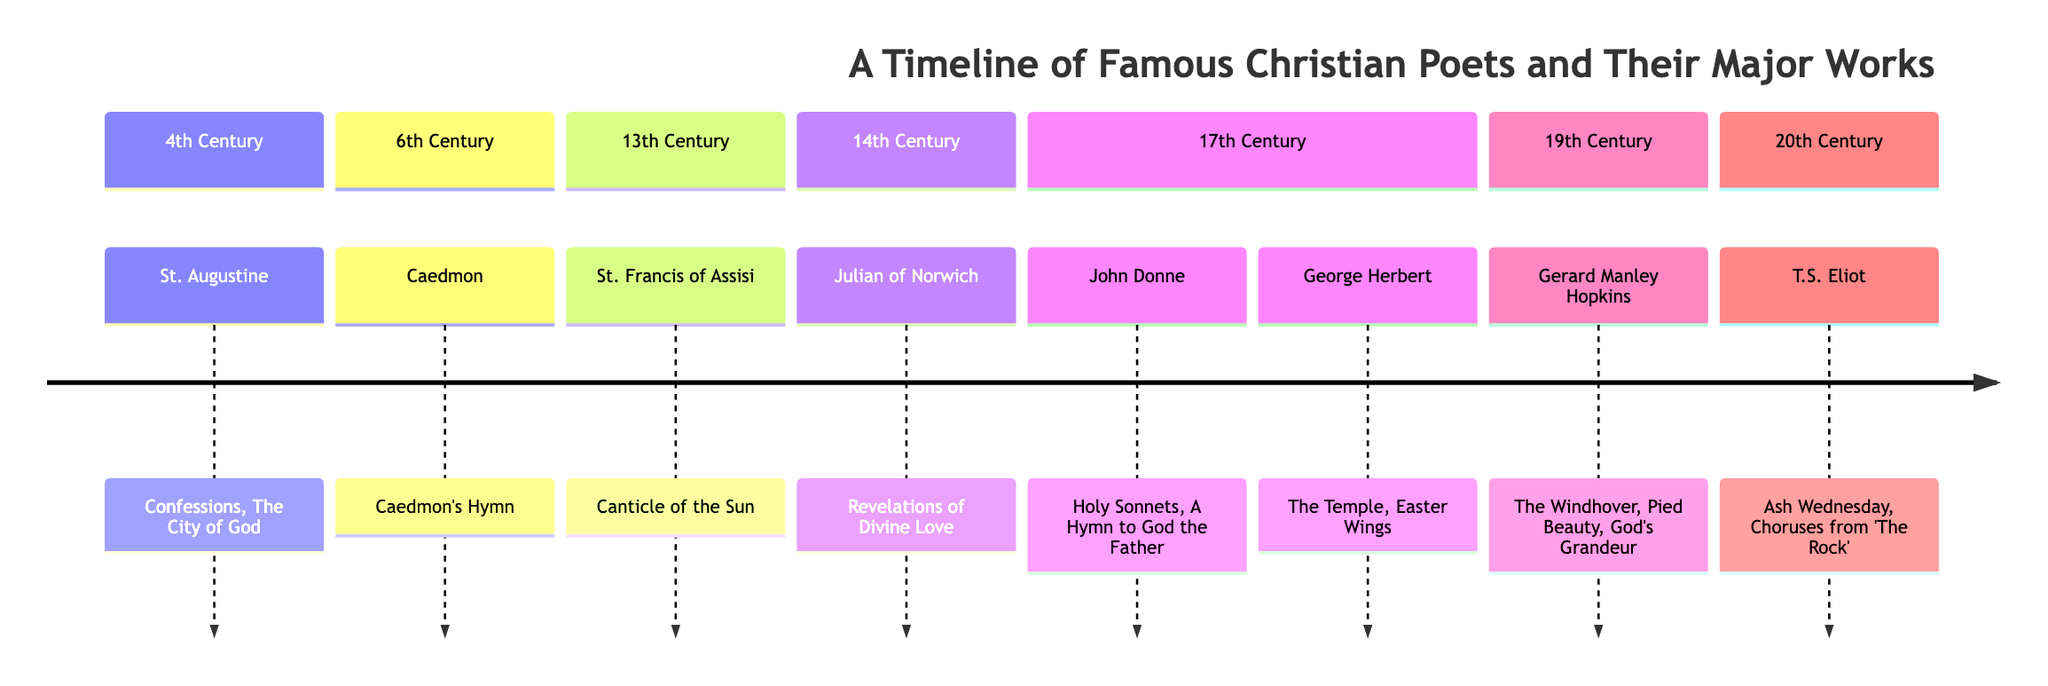What poet is associated with the 14th century? In the timeline, we look for the section labeled '14th Century'. Within this section, the poet listed is Julian of Norwich.
Answer: Julian of Norwich Which work is attributed to St. Francis of Assisi? By checking the '13th Century' section of the timeline, we see that the major work mentioned for St. Francis of Assisi is 'Canticle of the Sun'.
Answer: Canticle of the Sun How many major works does Gerard Manley Hopkins have listed? To find the number of works attributed to Gerard Manley Hopkins, we refer to the '19th Century' section, where three works are listed: 'The Windhover', 'Pied Beauty', and 'God's Grandeur'.
Answer: 3 Which century is John Donne from? We look at the '17th Century' section of the diagram, where John Donne is positioned. Therefore, he is from the 17th century.
Answer: 17th Century What are the major works of George Herbert? In the timeline, under the '17th Century' section, George Herbert is associated with two major works: 'The Temple' and 'Easter Wings'.
Answer: The Temple, Easter Wings Which poet comes immediately after St. Augustine in the timeline? To find this, we reference the '4th Century' section for St. Augustine and look to the next section, which is '6th Century' where Caedmon is listed.
Answer: Caedmon How many poets are represented in the 17th century? Moving to the '17th Century' section, we count the poets listed — John Donne and George Herbert — giving us two poets in total.
Answer: 2 What is a major work of T.S. Eliot? Referring to the '20th Century' section, we see that T.S. Eliot has listed major works including 'Ash Wednesday' and 'Choruses from The Rock'. Either one can be deemed correct.
Answer: Ash Wednesday Which poet is known for 'Revelations of Divine Love'? In the '14th Century' section, we find that the major work 'Revelations of Divine Love' is associated with Julian of Norwich.
Answer: Julian of Norwich 